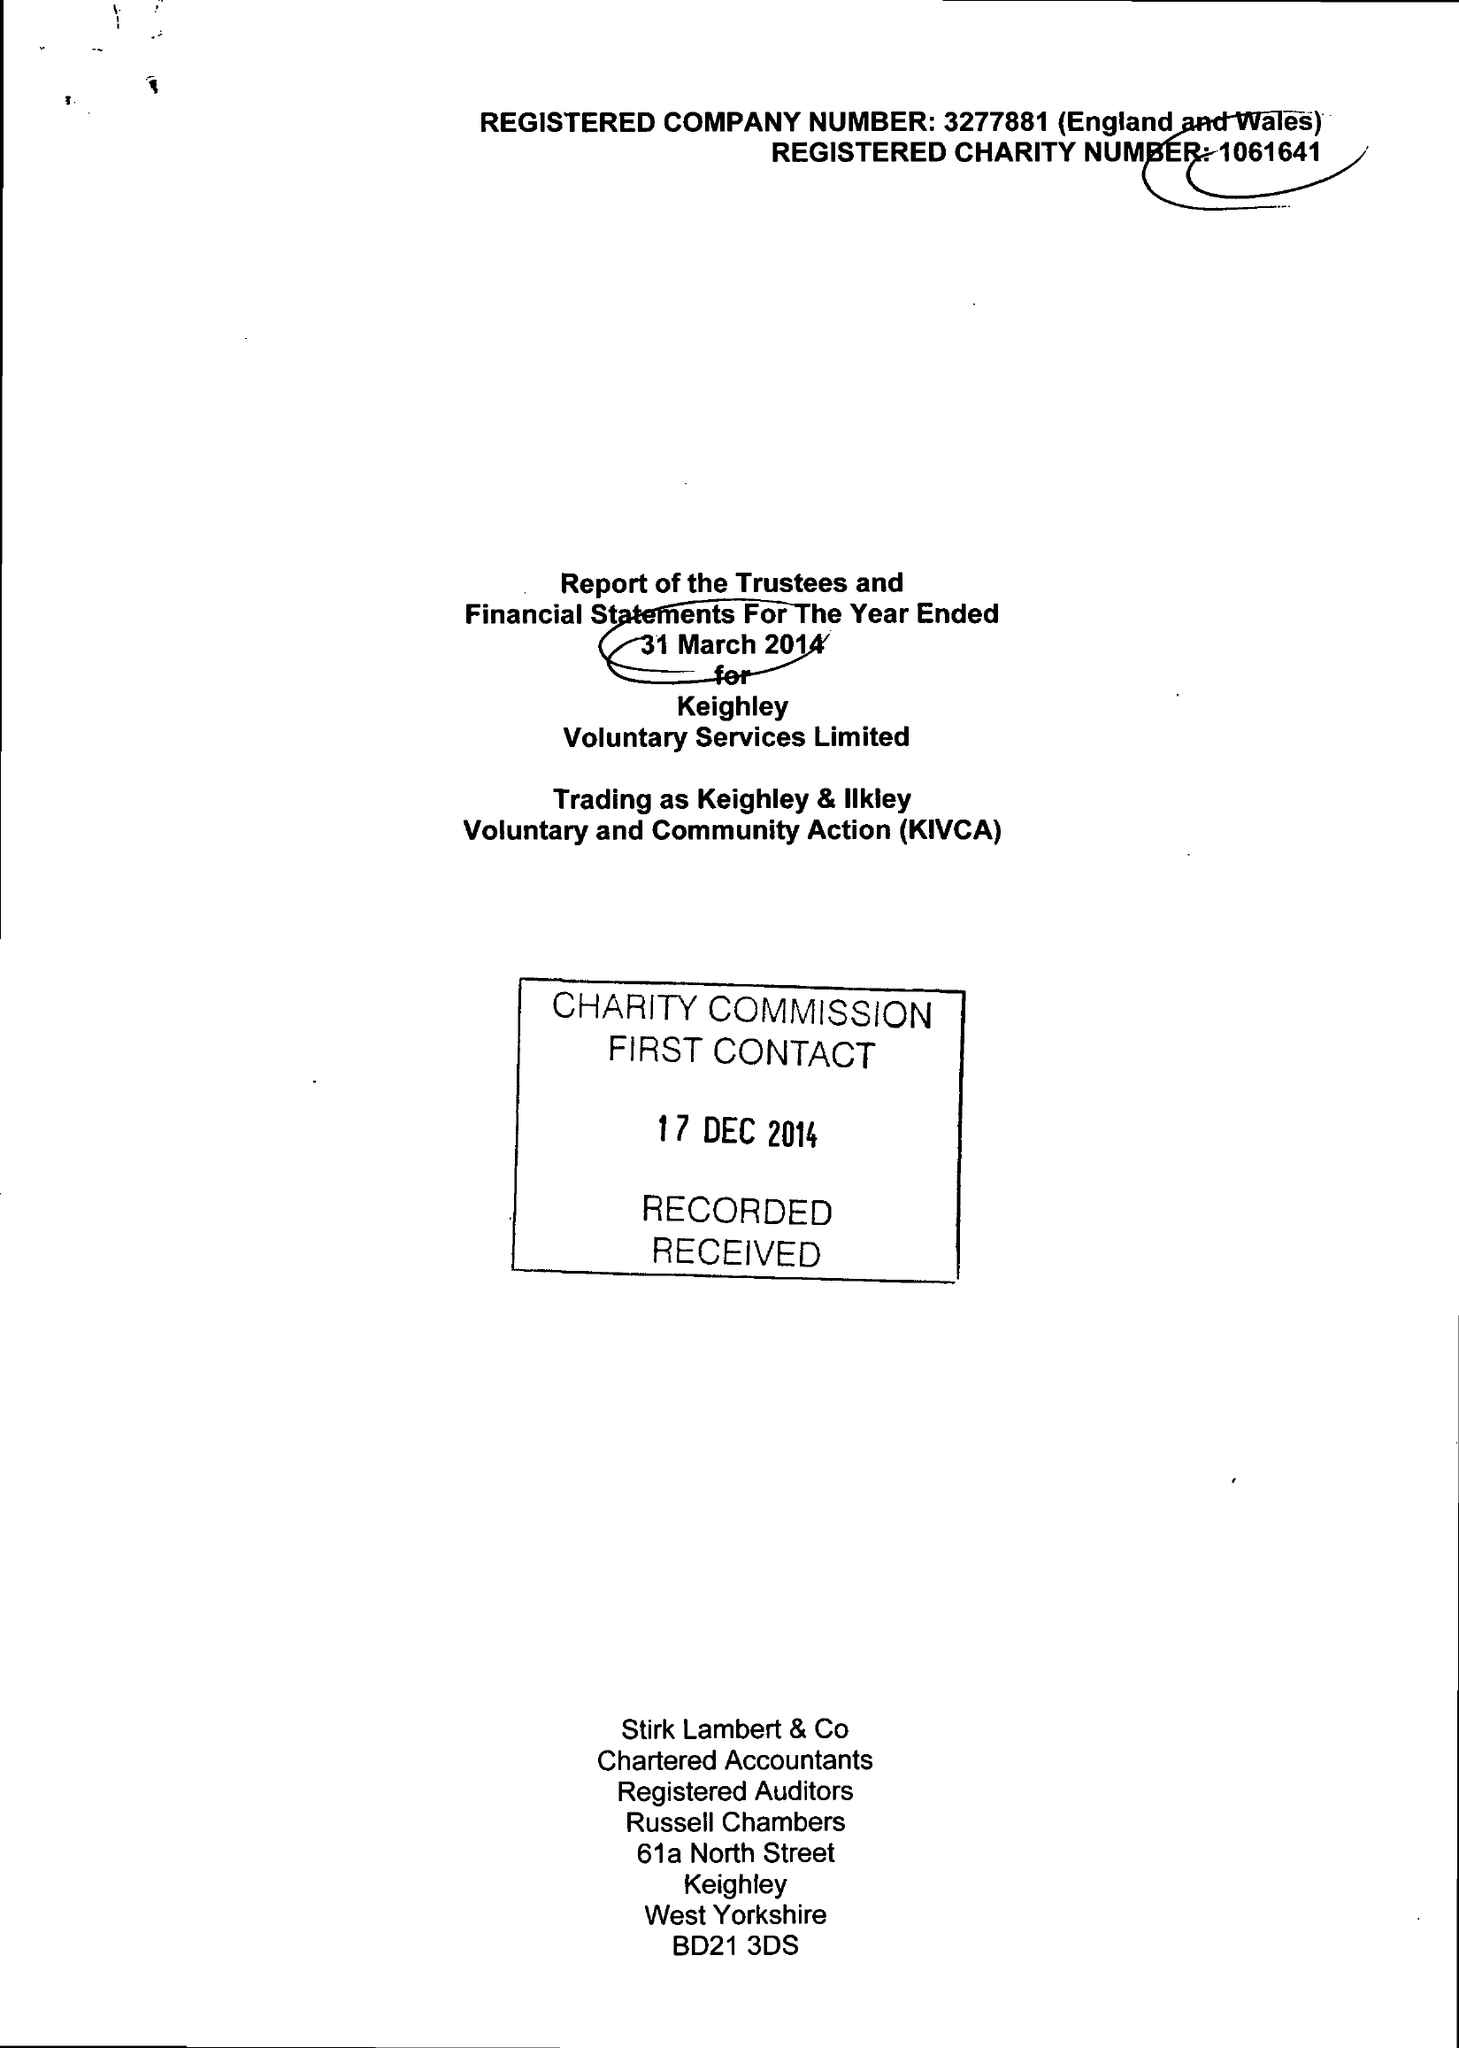What is the value for the report_date?
Answer the question using a single word or phrase. 2014-03-31 